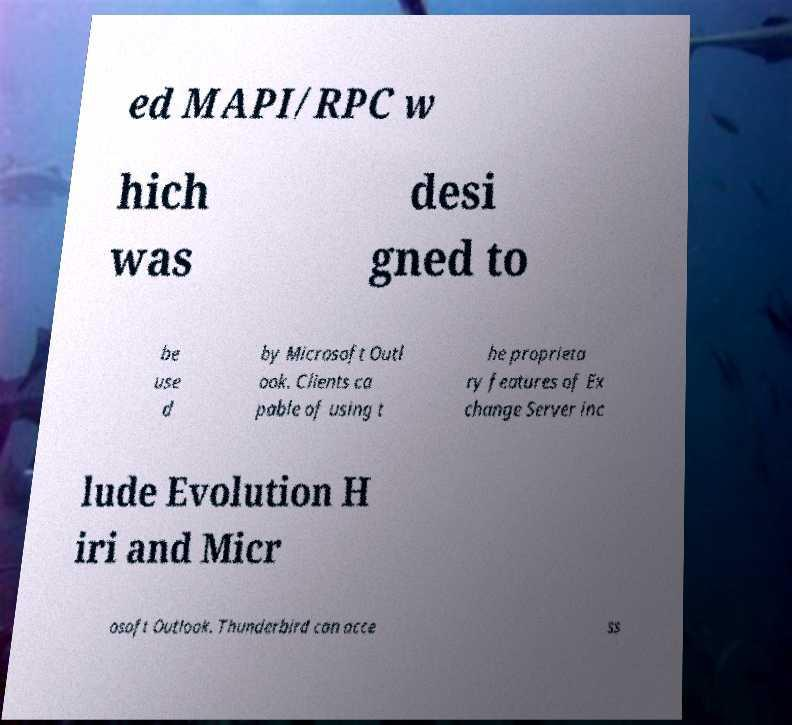What messages or text are displayed in this image? I need them in a readable, typed format. ed MAPI/RPC w hich was desi gned to be use d by Microsoft Outl ook. Clients ca pable of using t he proprieta ry features of Ex change Server inc lude Evolution H iri and Micr osoft Outlook. Thunderbird can acce ss 